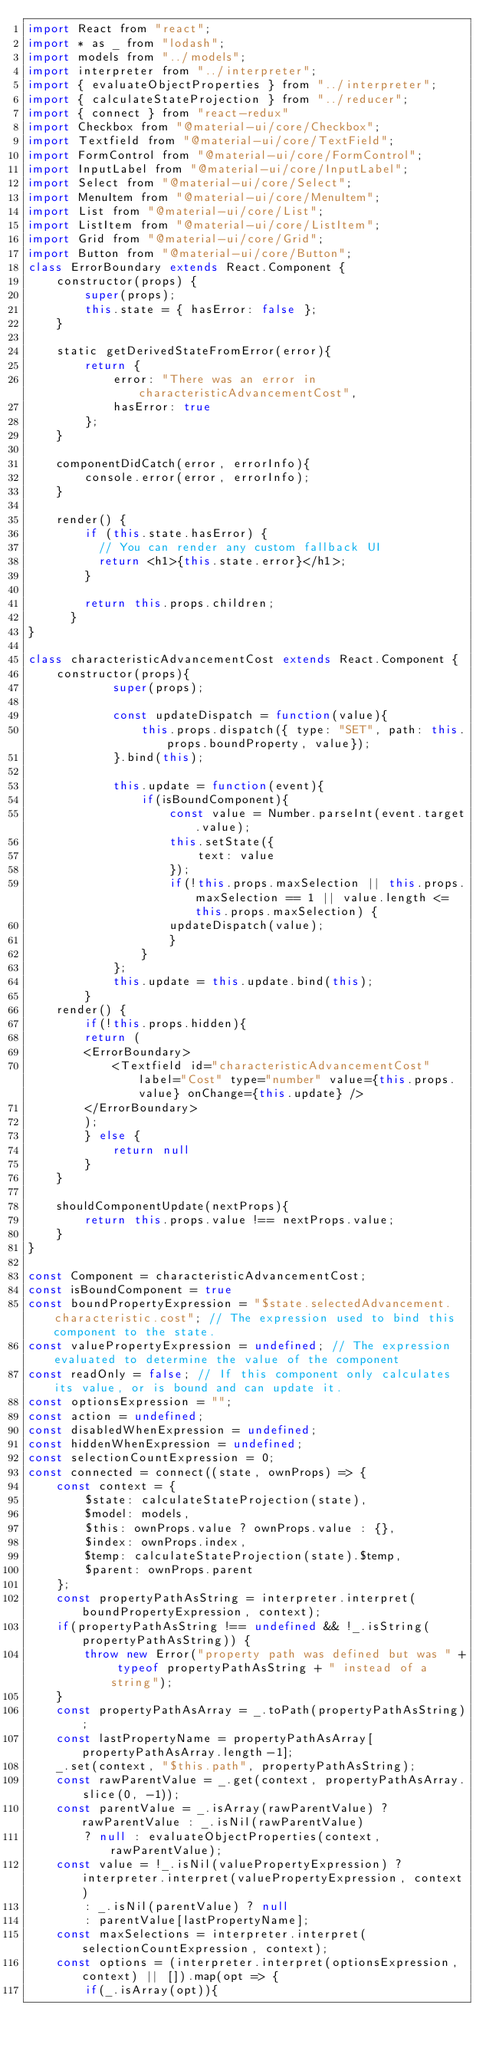<code> <loc_0><loc_0><loc_500><loc_500><_JavaScript_>import React from "react";
import * as _ from "lodash";
import models from "../models";
import interpreter from "../interpreter";
import { evaluateObjectProperties } from "../interpreter";
import { calculateStateProjection } from "../reducer";
import { connect } from "react-redux"
import Checkbox from "@material-ui/core/Checkbox";
import Textfield from "@material-ui/core/TextField";
import FormControl from "@material-ui/core/FormControl";
import InputLabel from "@material-ui/core/InputLabel";
import Select from "@material-ui/core/Select";
import MenuItem from "@material-ui/core/MenuItem";
import List from "@material-ui/core/List";
import ListItem from "@material-ui/core/ListItem";
import Grid from "@material-ui/core/Grid";
import Button from "@material-ui/core/Button";
class ErrorBoundary extends React.Component {
    constructor(props) {
        super(props);
        this.state = { hasError: false };
    }

    static getDerivedStateFromError(error){
        return {
            error: "There was an error in characteristicAdvancementCost",
            hasError: true
        };
    }

    componentDidCatch(error, errorInfo){
        console.error(error, errorInfo);
    }

    render() {
        if (this.state.hasError) {
          // You can render any custom fallback UI
          return <h1>{this.state.error}</h1>;
        }

        return this.props.children;
      }
}

class characteristicAdvancementCost extends React.Component {
    constructor(props){
            super(props);

            const updateDispatch = function(value){
                this.props.dispatch({ type: "SET", path: this.props.boundProperty, value});
            }.bind(this);

            this.update = function(event){
                if(isBoundComponent){
                    const value = Number.parseInt(event.target.value);
                    this.setState({
                        text: value
                    });
                    if(!this.props.maxSelection || this.props.maxSelection == 1 || value.length <= this.props.maxSelection) {
                    updateDispatch(value);
                    }
                }
            };
            this.update = this.update.bind(this);
        }
    render() {
        if(!this.props.hidden){
        return (
        <ErrorBoundary>
            <Textfield id="characteristicAdvancementCost" label="Cost" type="number" value={this.props.value} onChange={this.update} />
        </ErrorBoundary>
        );
        } else {
            return null
        }
    }

    shouldComponentUpdate(nextProps){
        return this.props.value !== nextProps.value;
    }
}

const Component = characteristicAdvancementCost;
const isBoundComponent = true
const boundPropertyExpression = "$state.selectedAdvancement.characteristic.cost"; // The expression used to bind this component to the state.
const valuePropertyExpression = undefined; // The expression evaluated to determine the value of the component
const readOnly = false; // If this component only calculates its value, or is bound and can update it.
const optionsExpression = "";
const action = undefined;
const disabledWhenExpression = undefined;
const hiddenWhenExpression = undefined;
const selectionCountExpression = 0;
const connected = connect((state, ownProps) => {
    const context = {
        $state: calculateStateProjection(state),
        $model: models,
        $this: ownProps.value ? ownProps.value : {},
        $index: ownProps.index,
        $temp: calculateStateProjection(state).$temp,
        $parent: ownProps.parent
    };
    const propertyPathAsString = interpreter.interpret(boundPropertyExpression, context);
    if(propertyPathAsString !== undefined && !_.isString(propertyPathAsString)) {
        throw new Error("property path was defined but was " + typeof propertyPathAsString + " instead of a string");
    }
    const propertyPathAsArray = _.toPath(propertyPathAsString);
    const lastPropertyName = propertyPathAsArray[propertyPathAsArray.length-1];
    _.set(context, "$this.path", propertyPathAsString);
    const rawParentValue = _.get(context, propertyPathAsArray.slice(0, -1));
    const parentValue = _.isArray(rawParentValue) ? rawParentValue : _.isNil(rawParentValue)
        ? null : evaluateObjectProperties(context, rawParentValue);
    const value = !_.isNil(valuePropertyExpression) ? interpreter.interpret(valuePropertyExpression, context)
        : _.isNil(parentValue) ? null
        : parentValue[lastPropertyName];
    const maxSelections = interpreter.interpret(selectionCountExpression, context);
    const options = (interpreter.interpret(optionsExpression, context) || []).map(opt => {
        if(_.isArray(opt)){</code> 